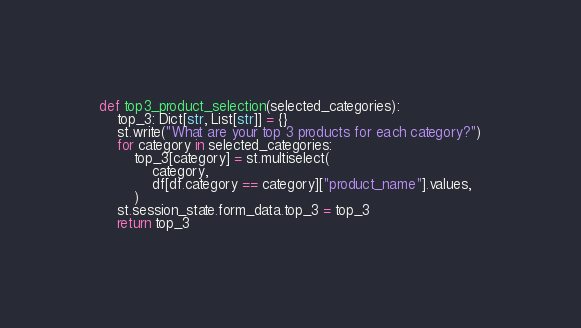Convert code to text. <code><loc_0><loc_0><loc_500><loc_500><_Python_>
def top3_product_selection(selected_categories):
    top_3: Dict[str, List[str]] = {}
    st.write("What are your top 3 products for each category?")
    for category in selected_categories:
        top_3[category] = st.multiselect(
            category,
            df[df.category == category]["product_name"].values,
        )
    st.session_state.form_data.top_3 = top_3
    return top_3

</code> 